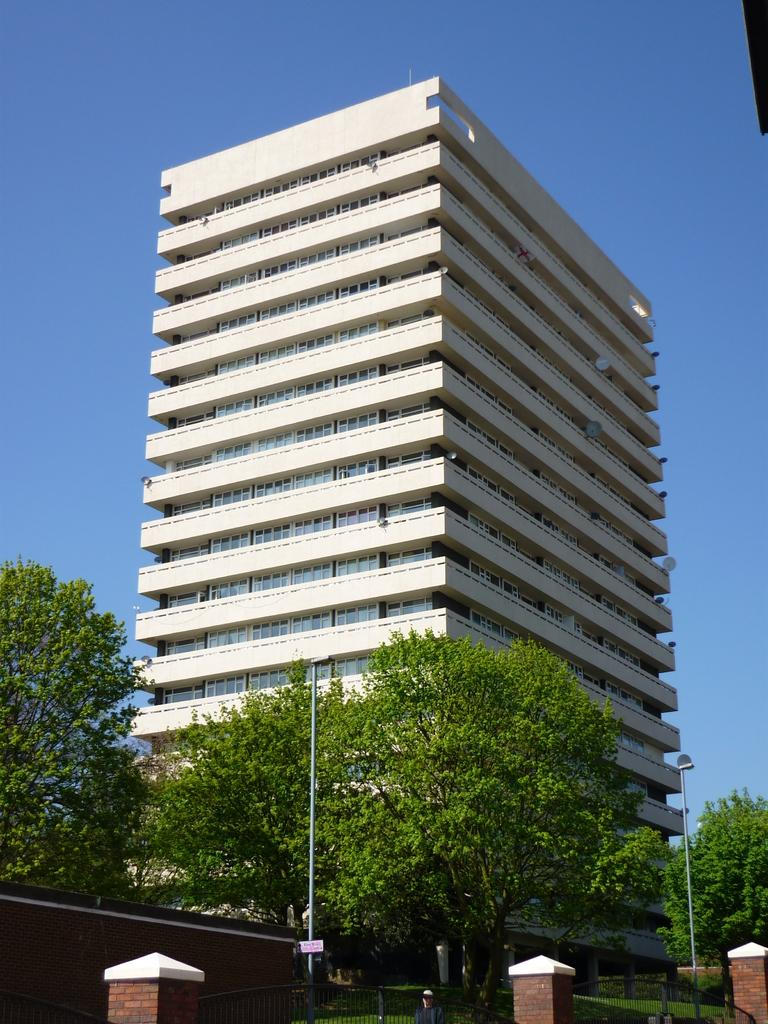What type of structure is visible in the image? There is a building in the image. What can be seen in the background of the image? The sky is visible behind the building. What is located at the bottom of the image? There is a gate, a pole, trees, and a person at the bottom of the image. What type of comfort can be seen in the notebook that the person is holding in the image? There is no notebook or comfort mentioned in the image; it only features a building, the sky, a gate, a pole, trees, and a person. 